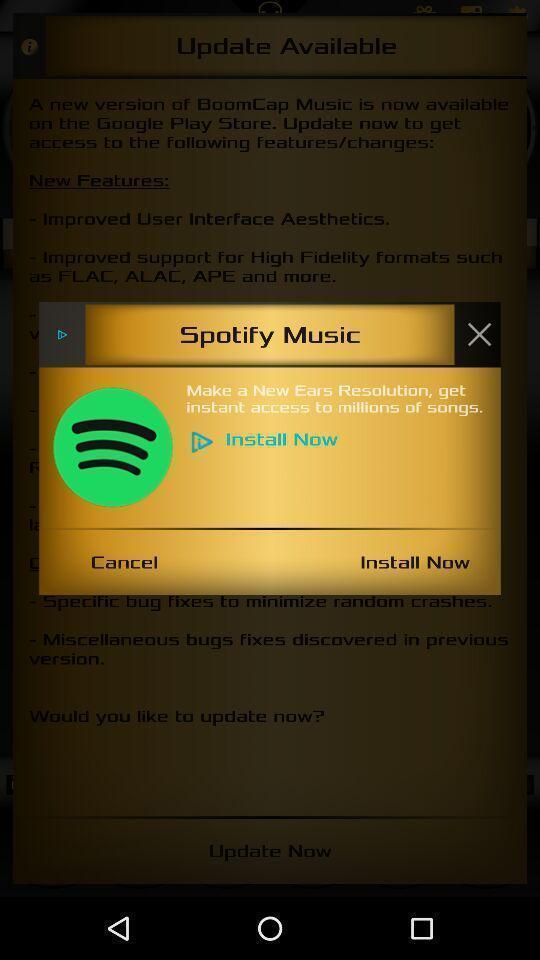Describe the key features of this screenshot. Pop-up shows to install a music app. 